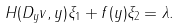Convert formula to latex. <formula><loc_0><loc_0><loc_500><loc_500>H ( D _ { y } v , y ) \xi _ { 1 } + f ( y ) \xi _ { 2 } = \lambda .</formula> 